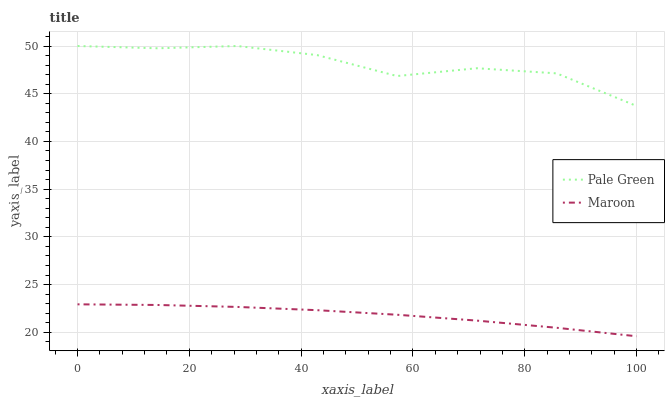Does Maroon have the minimum area under the curve?
Answer yes or no. Yes. Does Pale Green have the maximum area under the curve?
Answer yes or no. Yes. Does Maroon have the maximum area under the curve?
Answer yes or no. No. Is Maroon the smoothest?
Answer yes or no. Yes. Is Pale Green the roughest?
Answer yes or no. Yes. Is Maroon the roughest?
Answer yes or no. No. Does Maroon have the lowest value?
Answer yes or no. Yes. Does Pale Green have the highest value?
Answer yes or no. Yes. Does Maroon have the highest value?
Answer yes or no. No. Is Maroon less than Pale Green?
Answer yes or no. Yes. Is Pale Green greater than Maroon?
Answer yes or no. Yes. Does Maroon intersect Pale Green?
Answer yes or no. No. 